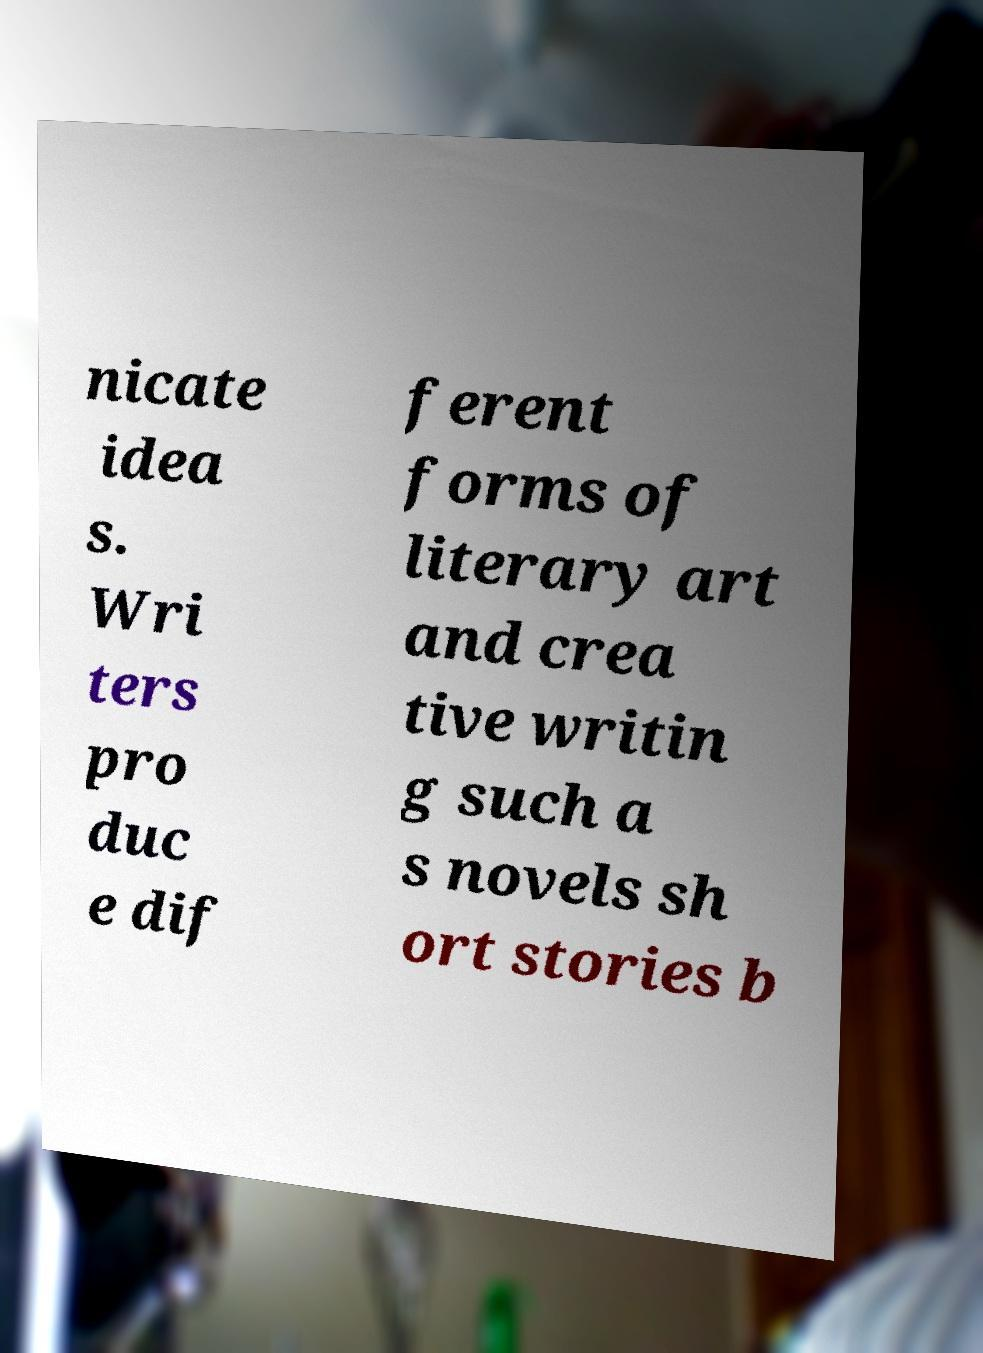Could you extract and type out the text from this image? nicate idea s. Wri ters pro duc e dif ferent forms of literary art and crea tive writin g such a s novels sh ort stories b 